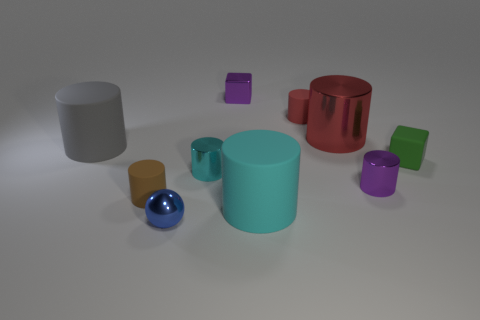Are there any metal cylinders of the same color as the small ball?
Your response must be concise. No. What is the color of the metal ball that is the same size as the green rubber block?
Ensure brevity in your answer.  Blue. There is a big object that is on the left side of the brown cylinder; does it have the same color as the shiny ball?
Provide a succinct answer. No. Is there a tiny brown object that has the same material as the tiny ball?
Your answer should be compact. No. There is a object that is the same color as the tiny shiny cube; what shape is it?
Your answer should be compact. Cylinder. Is the number of green things to the right of the tiny green cube less than the number of large yellow blocks?
Give a very brief answer. No. There is a red cylinder on the right side of the red rubber object; does it have the same size as the cyan matte cylinder?
Your response must be concise. Yes. What number of other small things are the same shape as the red rubber thing?
Your response must be concise. 3. There is a ball that is the same material as the tiny purple cube; what is its size?
Your response must be concise. Small. Are there the same number of gray rubber cylinders on the right side of the tiny brown rubber cylinder and tiny metal cubes?
Ensure brevity in your answer.  No. 